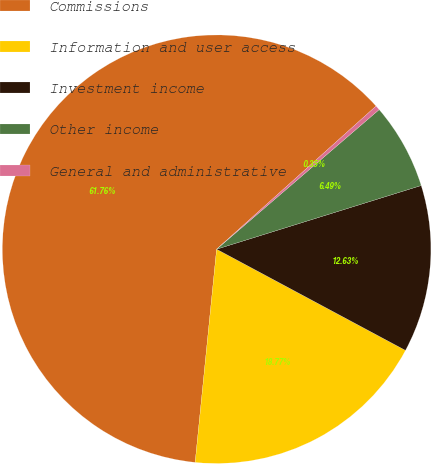Convert chart to OTSL. <chart><loc_0><loc_0><loc_500><loc_500><pie_chart><fcel>Commissions<fcel>Information and user access<fcel>Investment income<fcel>Other income<fcel>General and administrative<nl><fcel>61.76%<fcel>18.77%<fcel>12.63%<fcel>6.49%<fcel>0.35%<nl></chart> 